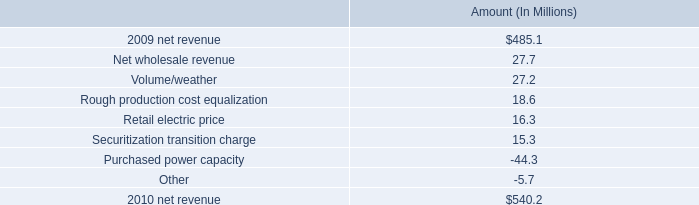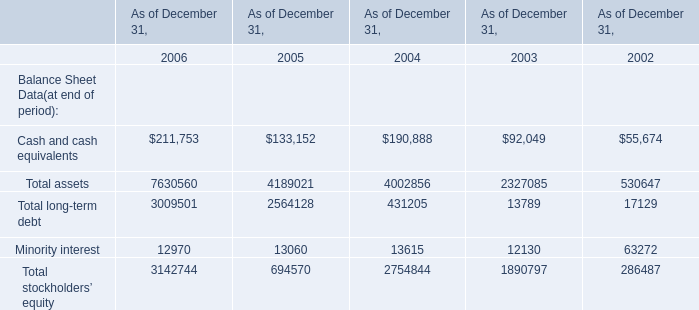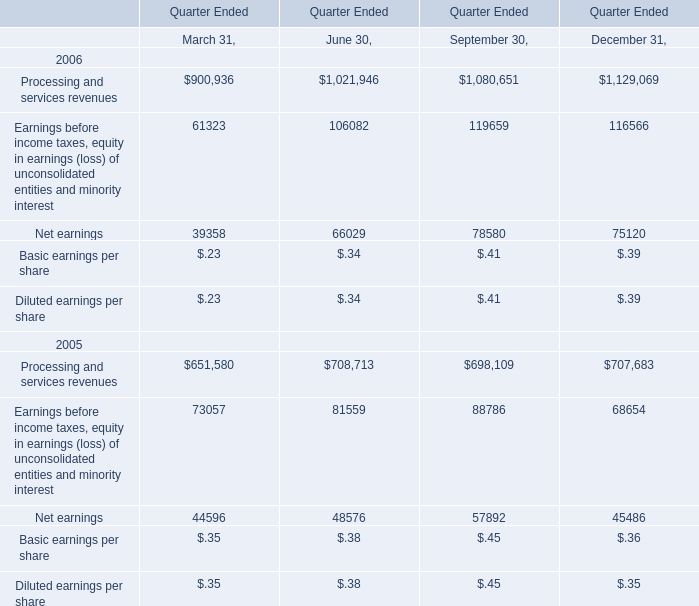In the year/section with the most Total assets, what is the growth rate of Minority interest? 
Computations: ((3142744 - 694570) / 3142744)
Answer: 0.77899. what was the percentage change in the net revenue in 2010 
Computations: ((540.2 - 485.1) / 485.1)
Answer: 0.11358. Which year has the greatest proportion of rocessing and services revenues? 
Answer: 2006. 